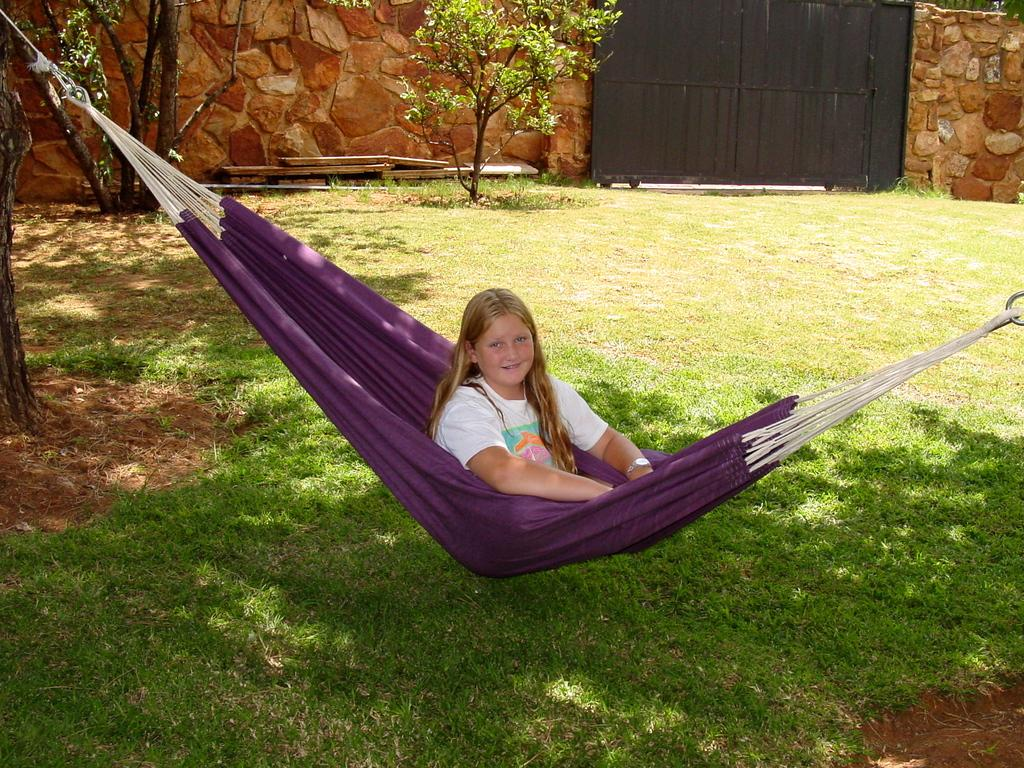Who is present in the image? There is a girl in the image. What is the girl doing in the image? The girl is sitting in a purple hammock. What type of vegetation can be seen in the image? There are plants and grass in the image. What structures are visible in the image? There is a wall and a gate in the image. What type of club can be seen in the image? There is no club present in the image. How does the girl slip out of the hammock in the image? The girl does not slip out of the hammock in the image; she is sitting in it. 